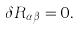Convert formula to latex. <formula><loc_0><loc_0><loc_500><loc_500>\delta R _ { \alpha \beta } = 0 .</formula> 